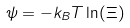Convert formula to latex. <formula><loc_0><loc_0><loc_500><loc_500>\psi = - k _ { B } T \ln ( \Xi )</formula> 